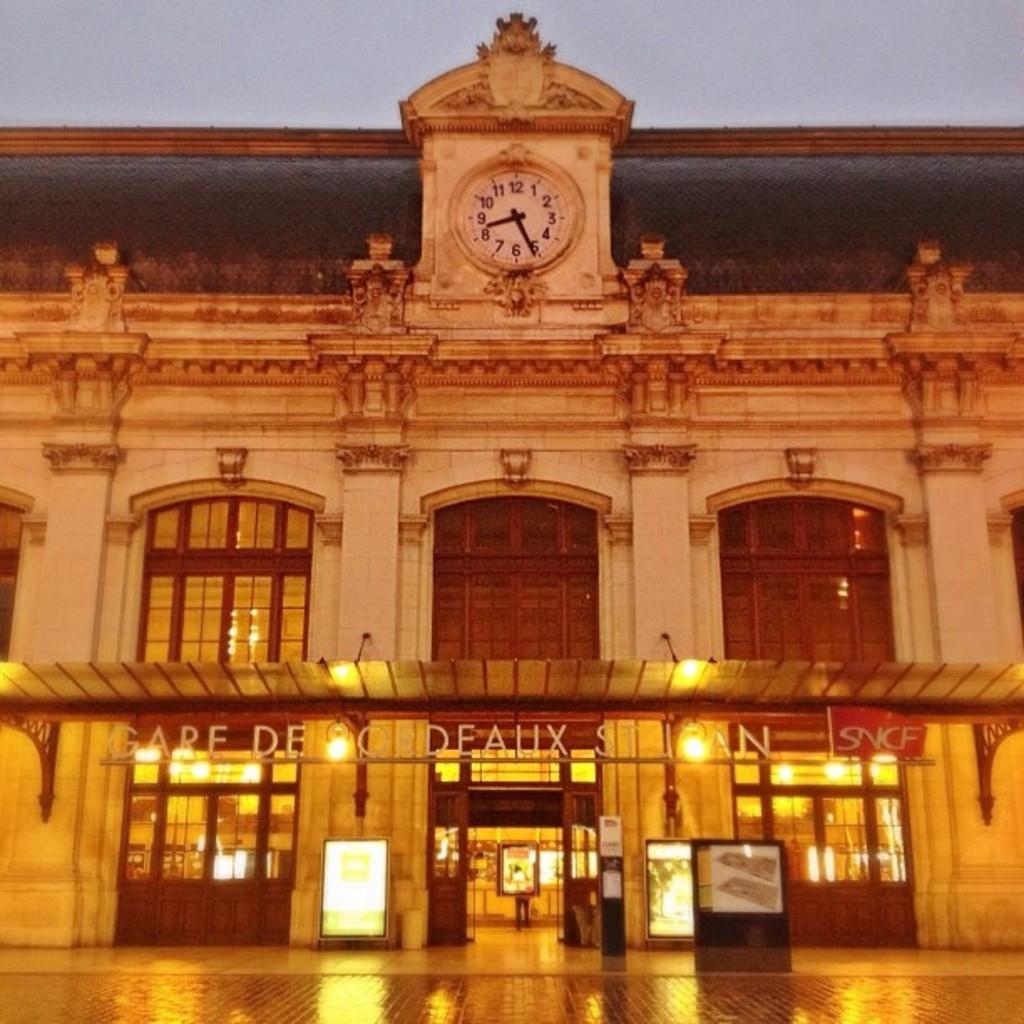In one or two sentences, can you explain what this image depicts? In the image there is a building in the back with many windows and doors and there is a clock above it, over the top its sky. 